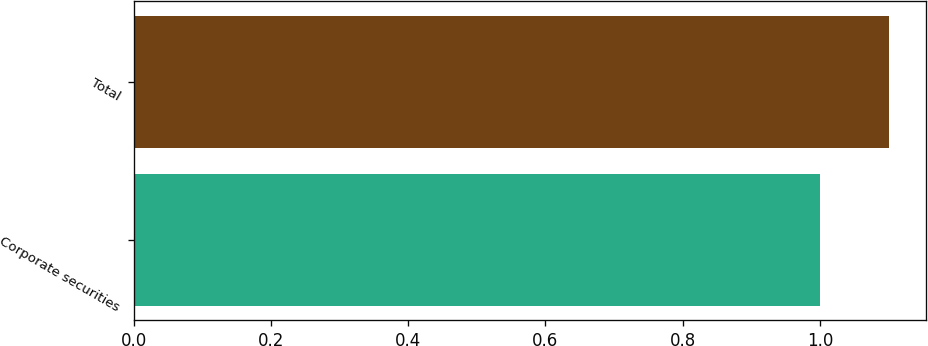<chart> <loc_0><loc_0><loc_500><loc_500><bar_chart><fcel>Corporate securities<fcel>Total<nl><fcel>1<fcel>1.1<nl></chart> 